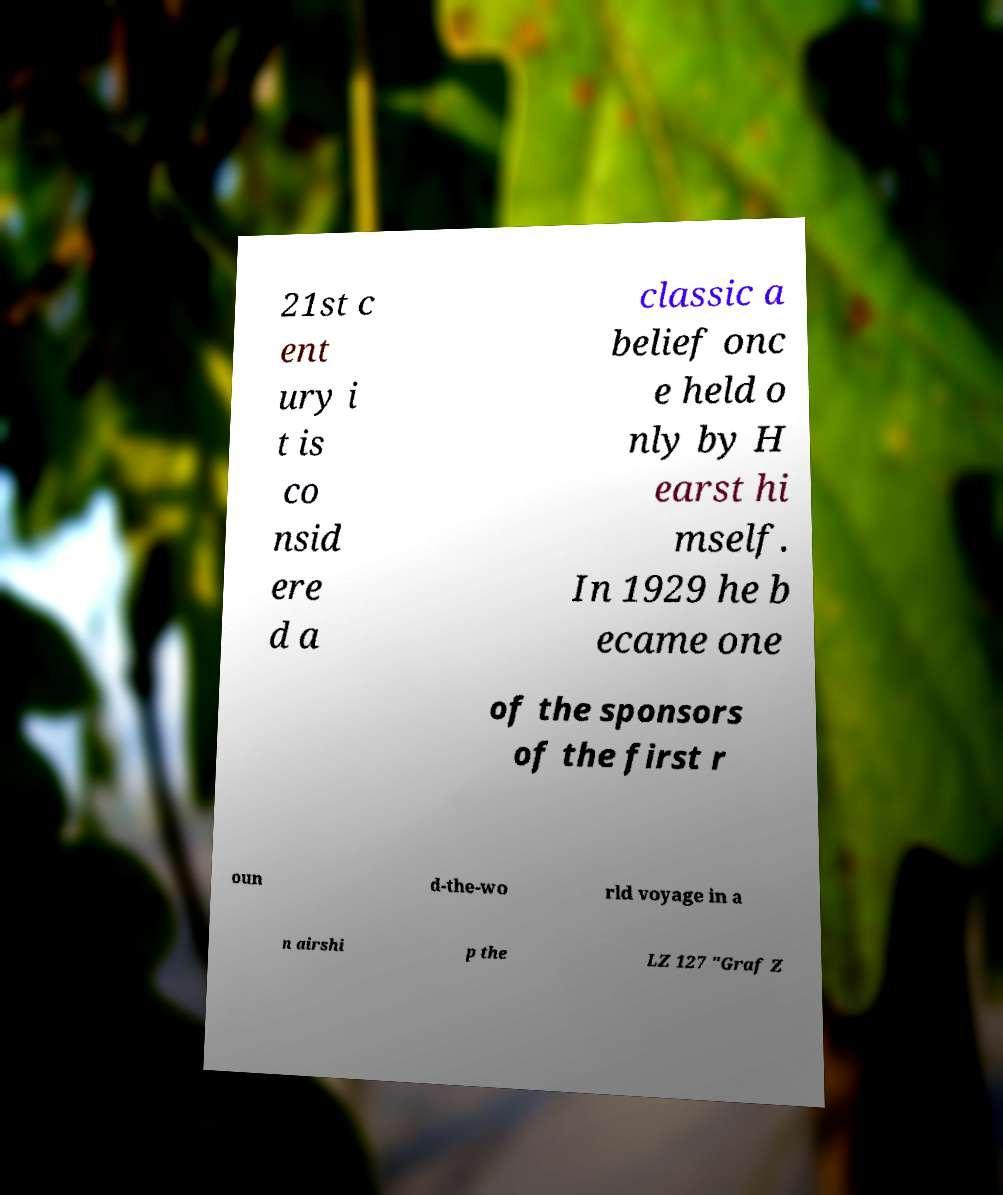Please read and relay the text visible in this image. What does it say? 21st c ent ury i t is co nsid ere d a classic a belief onc e held o nly by H earst hi mself. In 1929 he b ecame one of the sponsors of the first r oun d-the-wo rld voyage in a n airshi p the LZ 127 "Graf Z 